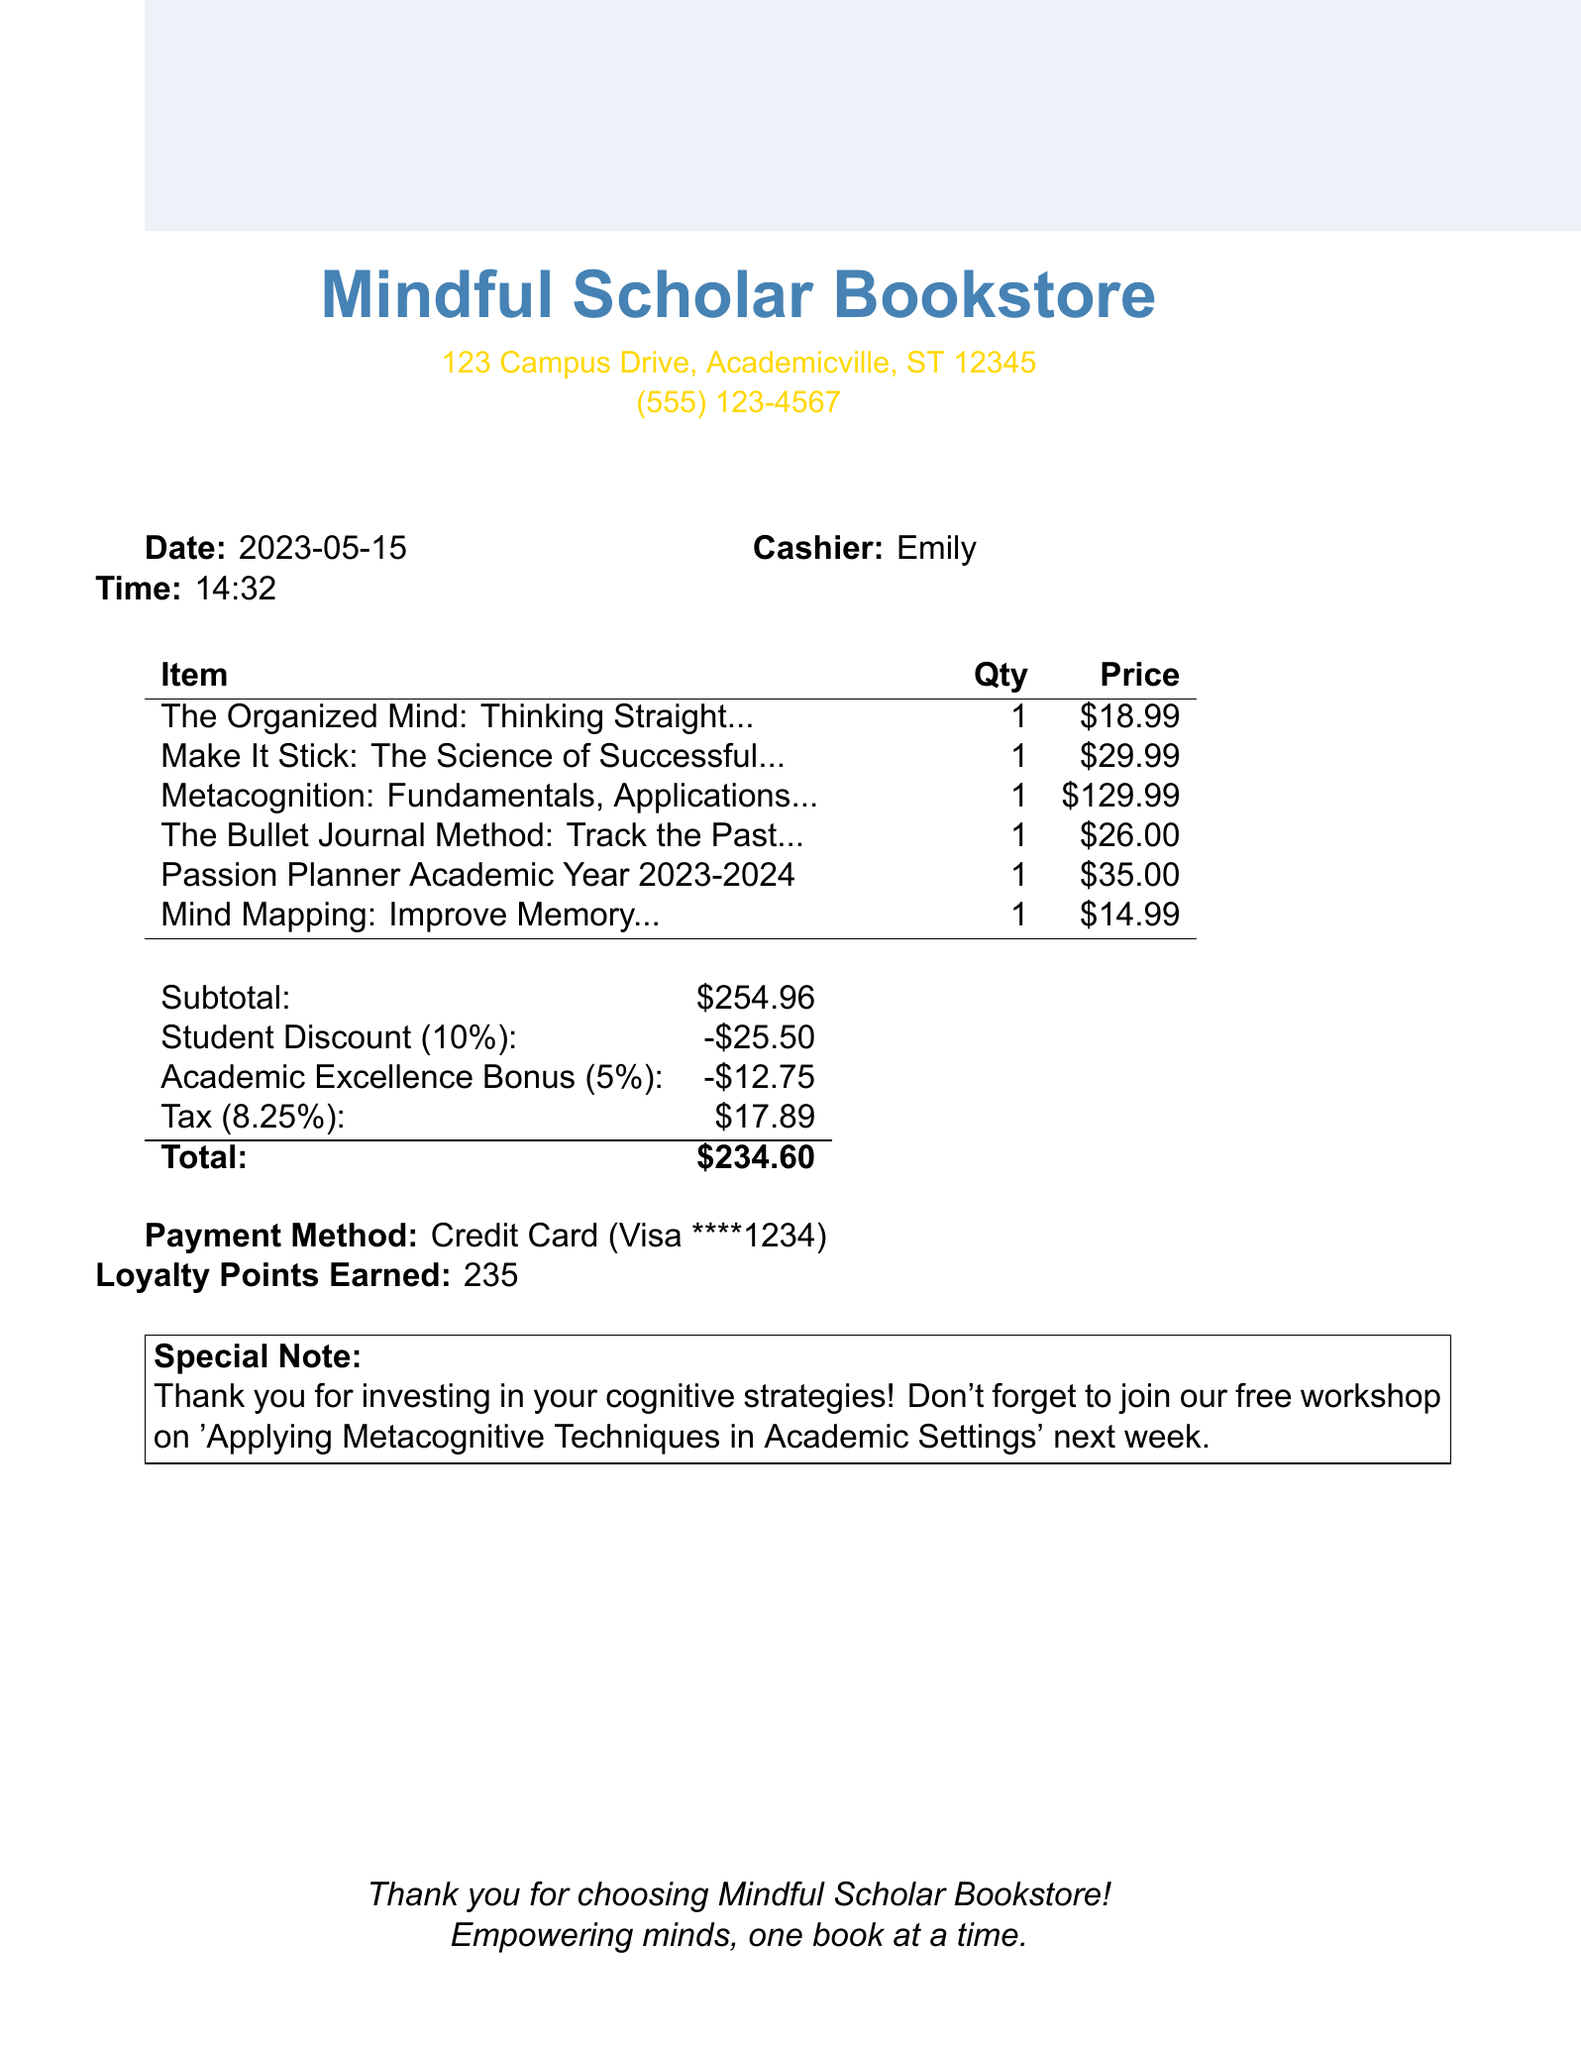What is the name of the bookstore? The name of the bookstore is listed at the top of the document.
Answer: Mindful Scholar Bookstore What is the date of purchase? The date of purchase is noted in the document's introductory section.
Answer: 2023-05-15 Who was the cashier for this transaction? The cashier's name is mentioned under the date and time section.
Answer: Emily What is the total amount after discounts and taxes? The total amount is provided at the end of the cost summary.
Answer: $234.60 What is the subtotal before discounts? The subtotal is stated in the table of costs before the discounts are applied.
Answer: $254.96 How much is the student discount? The discount percentage and amount are detailed in the discounts section.
Answer: $25.50 What types of payment methods are accepted? The payment method is specified towards the end of the receipt.
Answer: Credit Card How many loyalty points were earned? The number of loyalty points is mentioned just before the special note.
Answer: 235 What was the academic excellence bonus percentage? The percentage for the academic excellence bonus is included in the discounts section.
Answer: 5% 